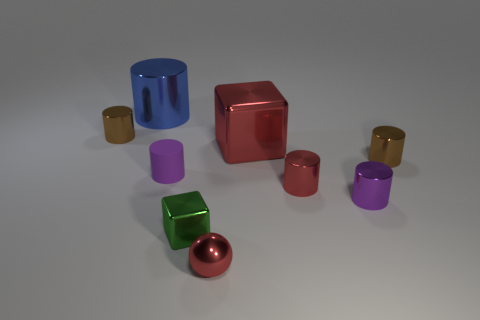Subtract all purple cylinders. How many cylinders are left? 4 Subtract all cyan balls. How many brown cylinders are left? 2 Add 1 purple cylinders. How many objects exist? 10 Subtract all green blocks. How many blocks are left? 1 Subtract all balls. How many objects are left? 8 Subtract 3 cylinders. How many cylinders are left? 3 Subtract 0 gray cylinders. How many objects are left? 9 Subtract all gray blocks. Subtract all blue balls. How many blocks are left? 2 Subtract all purple matte spheres. Subtract all red cubes. How many objects are left? 8 Add 6 big cylinders. How many big cylinders are left? 7 